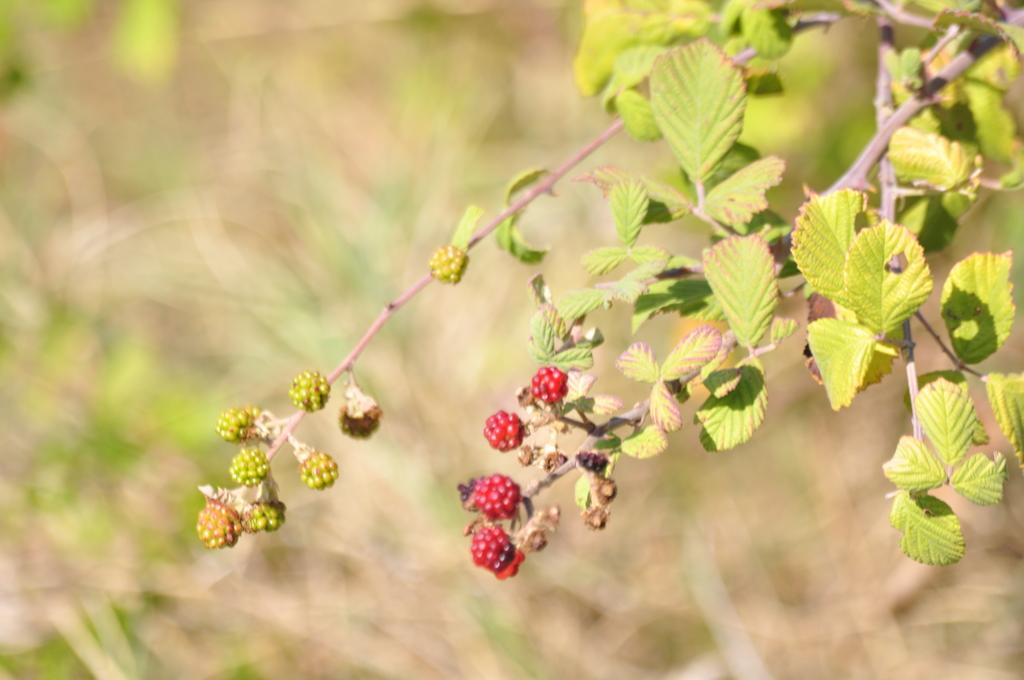What type of fruit can be seen on the plant in the image? There are berries on a plant in the image. Can you describe the background of the image? The background of the image is blurred. How many pigs are sleeping in the image? There are no pigs present in the image, and therefore no sleeping pigs can be observed. What type of musical instrument is being played in the image? There is no musical instrument being played in the image. 